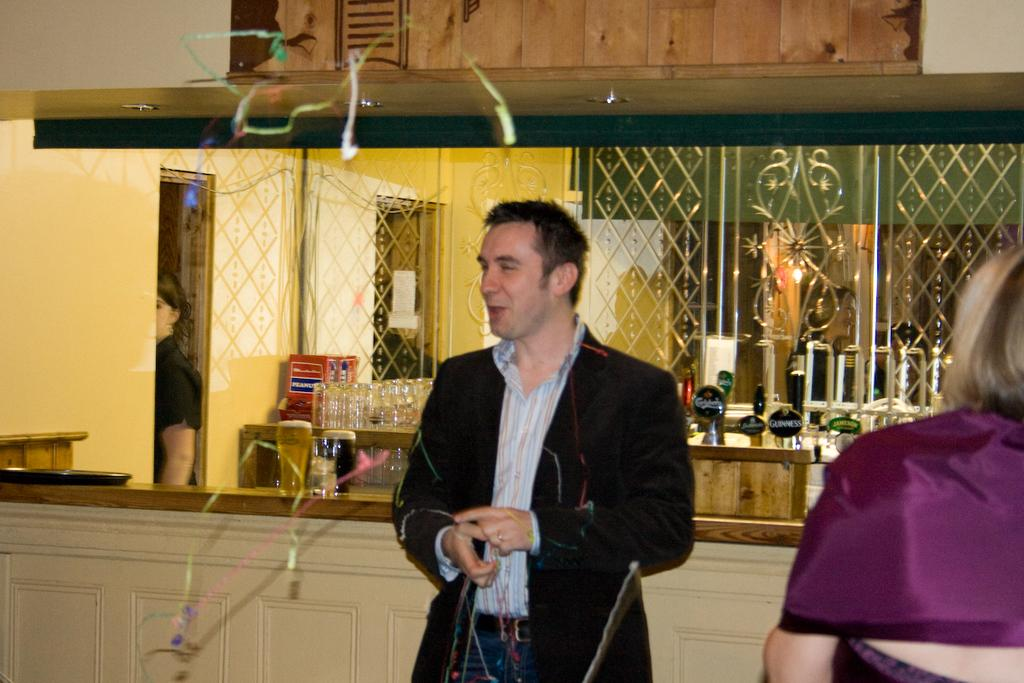What type of setting is shown in the image? The image depicts a bar setting. Can you describe the man in the image? There is a man standing in the middle of the image, and he is smiling. What is the man wearing? The man is wearing a coat, shirt, and trousers. What can be seen on the left side of the image? There are wine glasses on the left side of the image. What color is the poison that the man is holding in the image? There is no poison present in the image, and the man is not holding anything. 